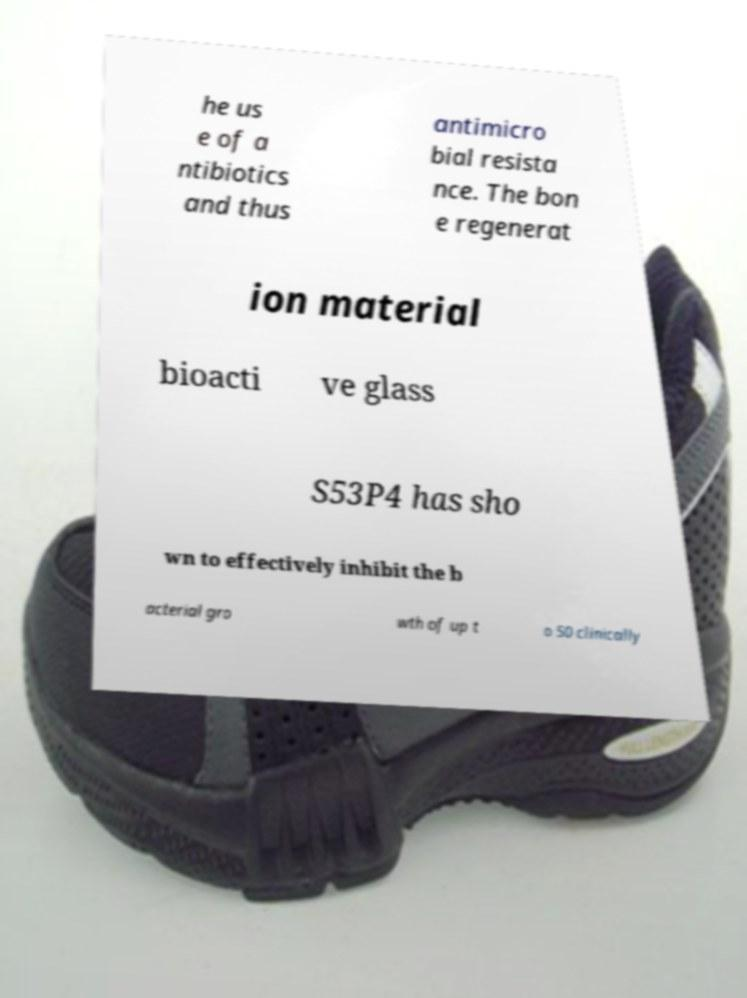There's text embedded in this image that I need extracted. Can you transcribe it verbatim? he us e of a ntibiotics and thus antimicro bial resista nce. The bon e regenerat ion material bioacti ve glass S53P4 has sho wn to effectively inhibit the b acterial gro wth of up t o 50 clinically 